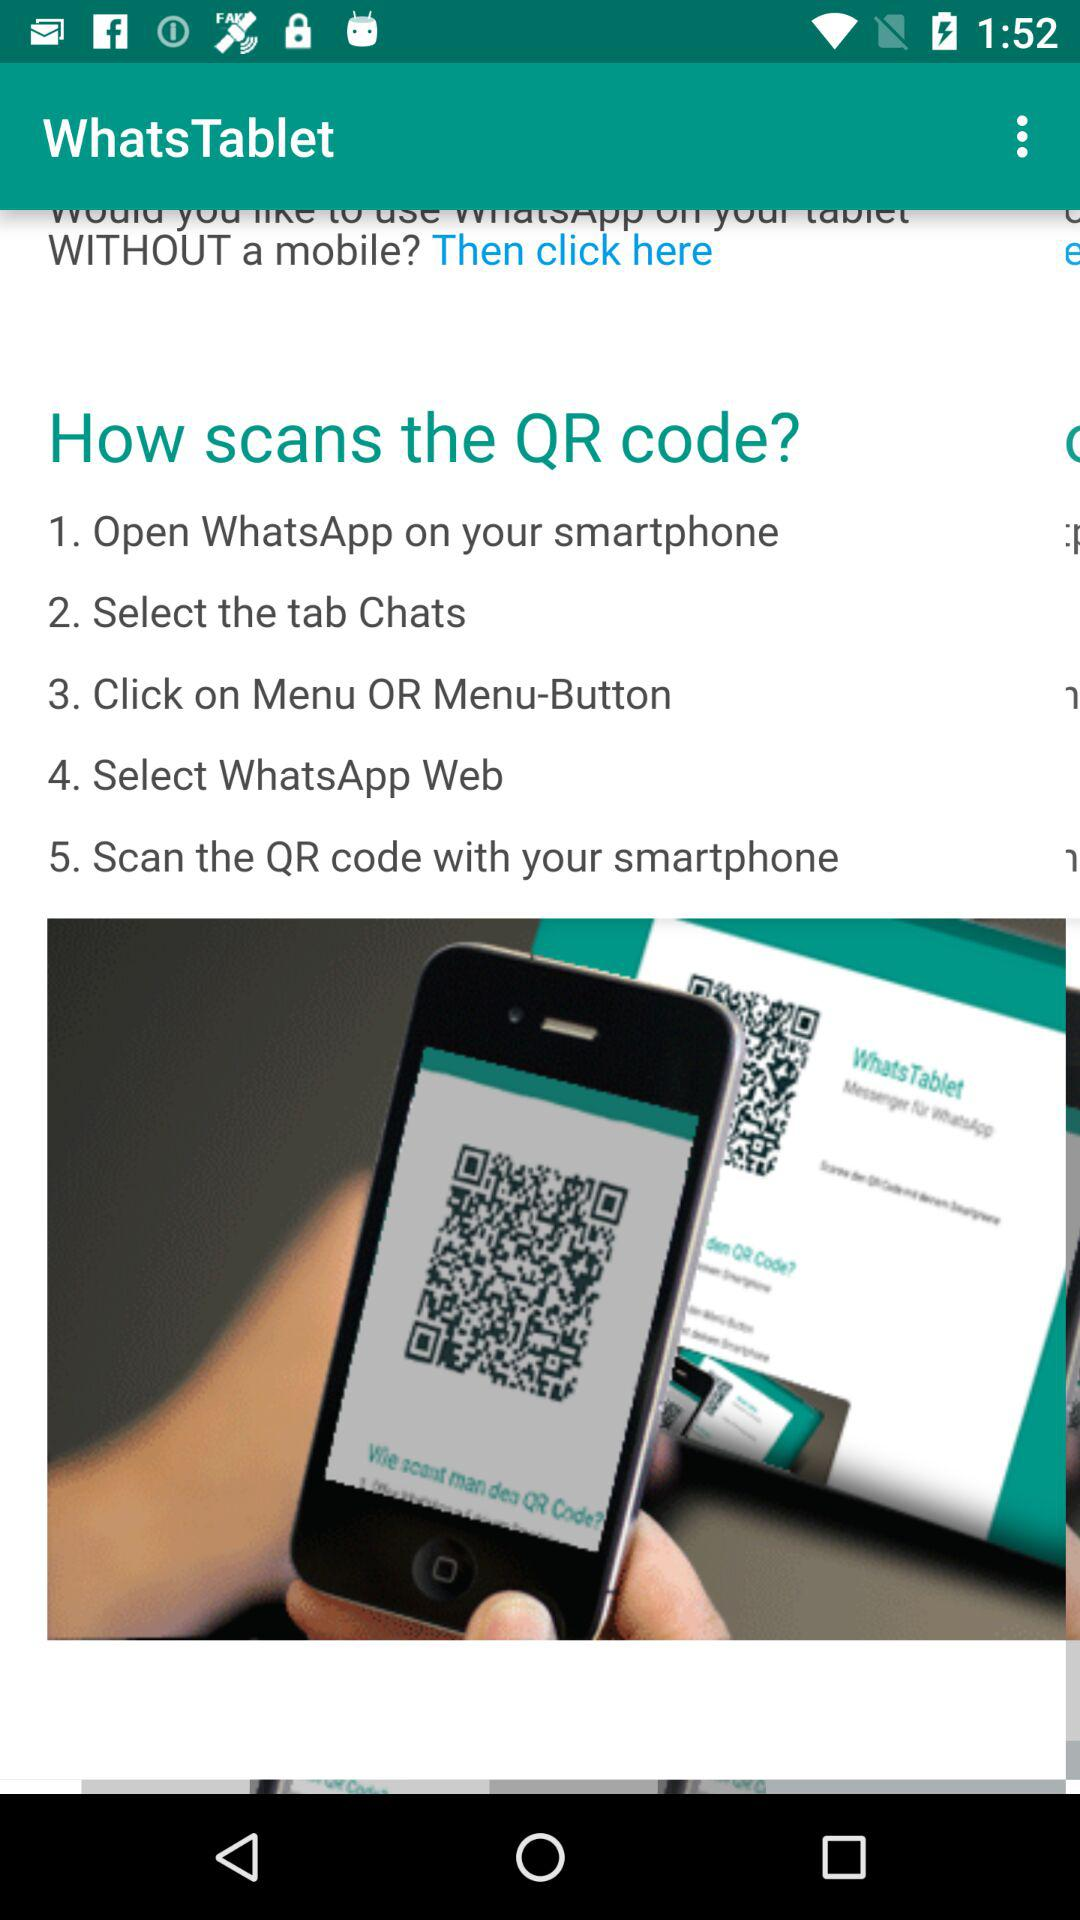How many steps are there in total?
Answer the question using a single word or phrase. 5 